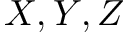Convert formula to latex. <formula><loc_0><loc_0><loc_500><loc_500>X , Y , Z</formula> 